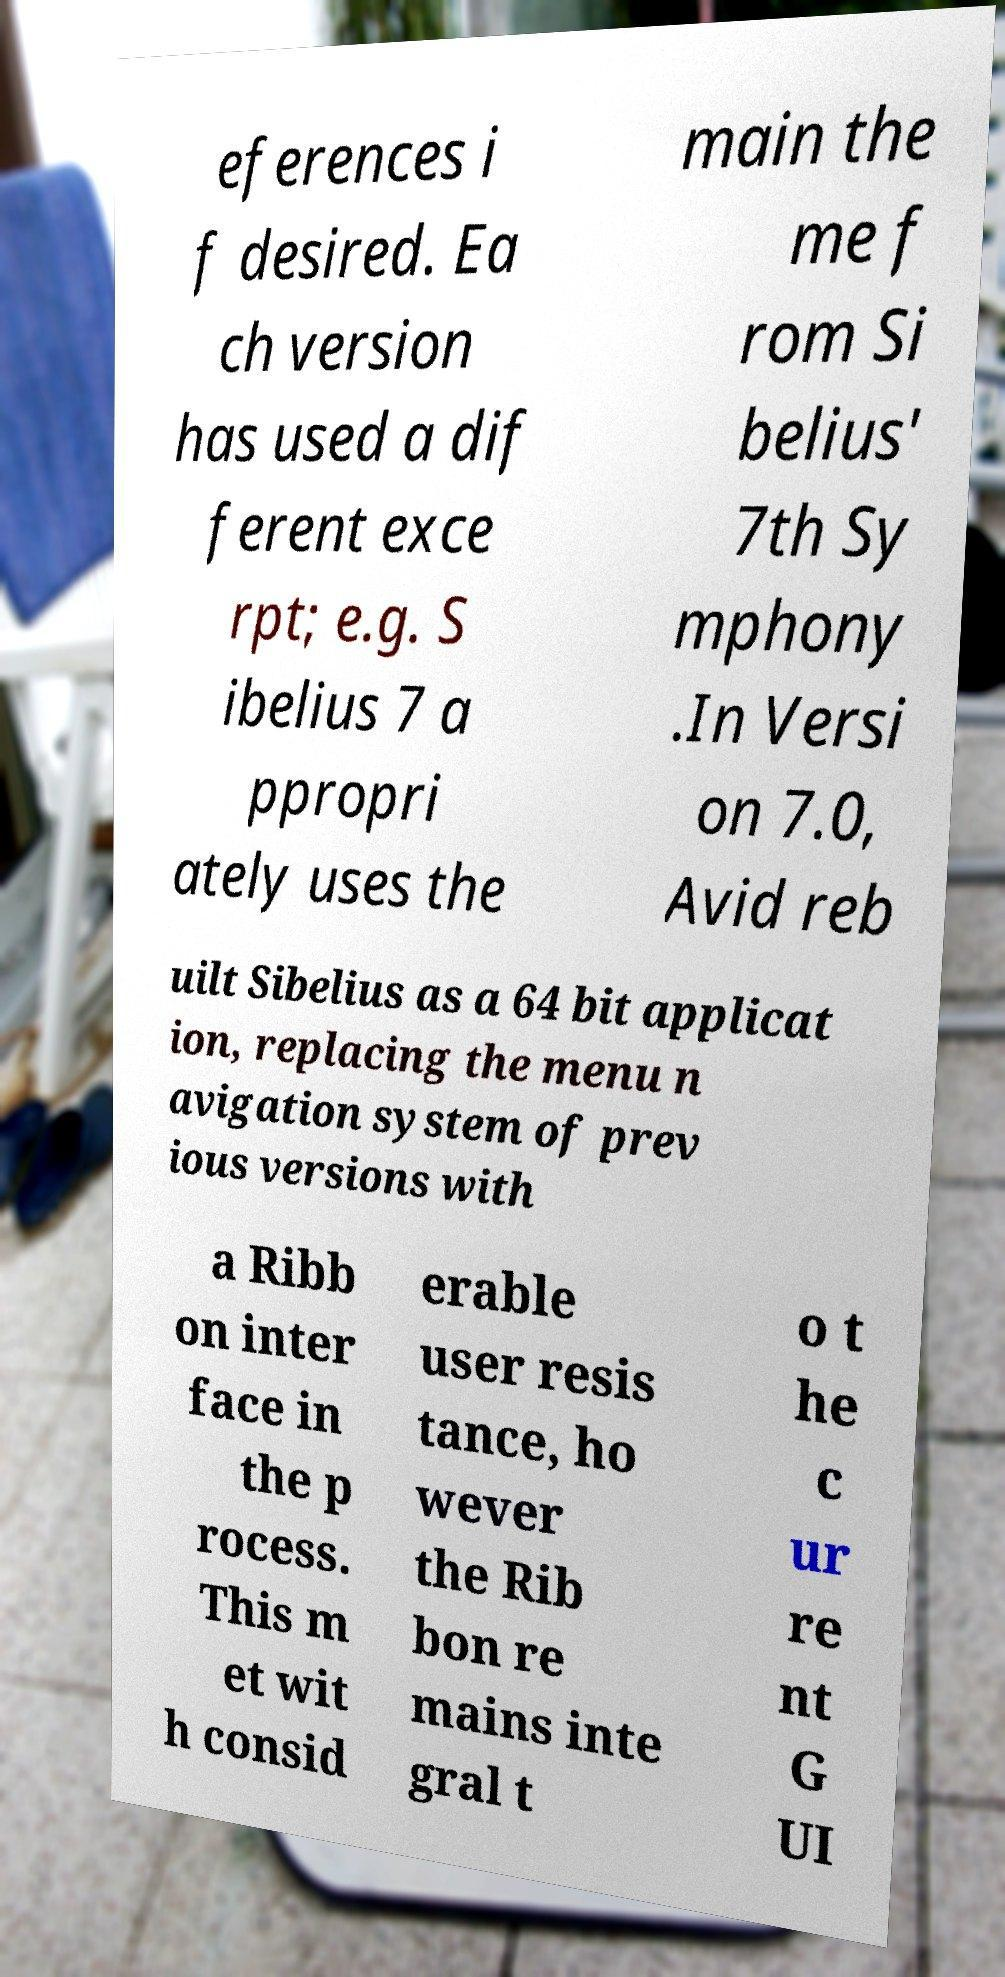I need the written content from this picture converted into text. Can you do that? eferences i f desired. Ea ch version has used a dif ferent exce rpt; e.g. S ibelius 7 a ppropri ately uses the main the me f rom Si belius' 7th Sy mphony .In Versi on 7.0, Avid reb uilt Sibelius as a 64 bit applicat ion, replacing the menu n avigation system of prev ious versions with a Ribb on inter face in the p rocess. This m et wit h consid erable user resis tance, ho wever the Rib bon re mains inte gral t o t he c ur re nt G UI 